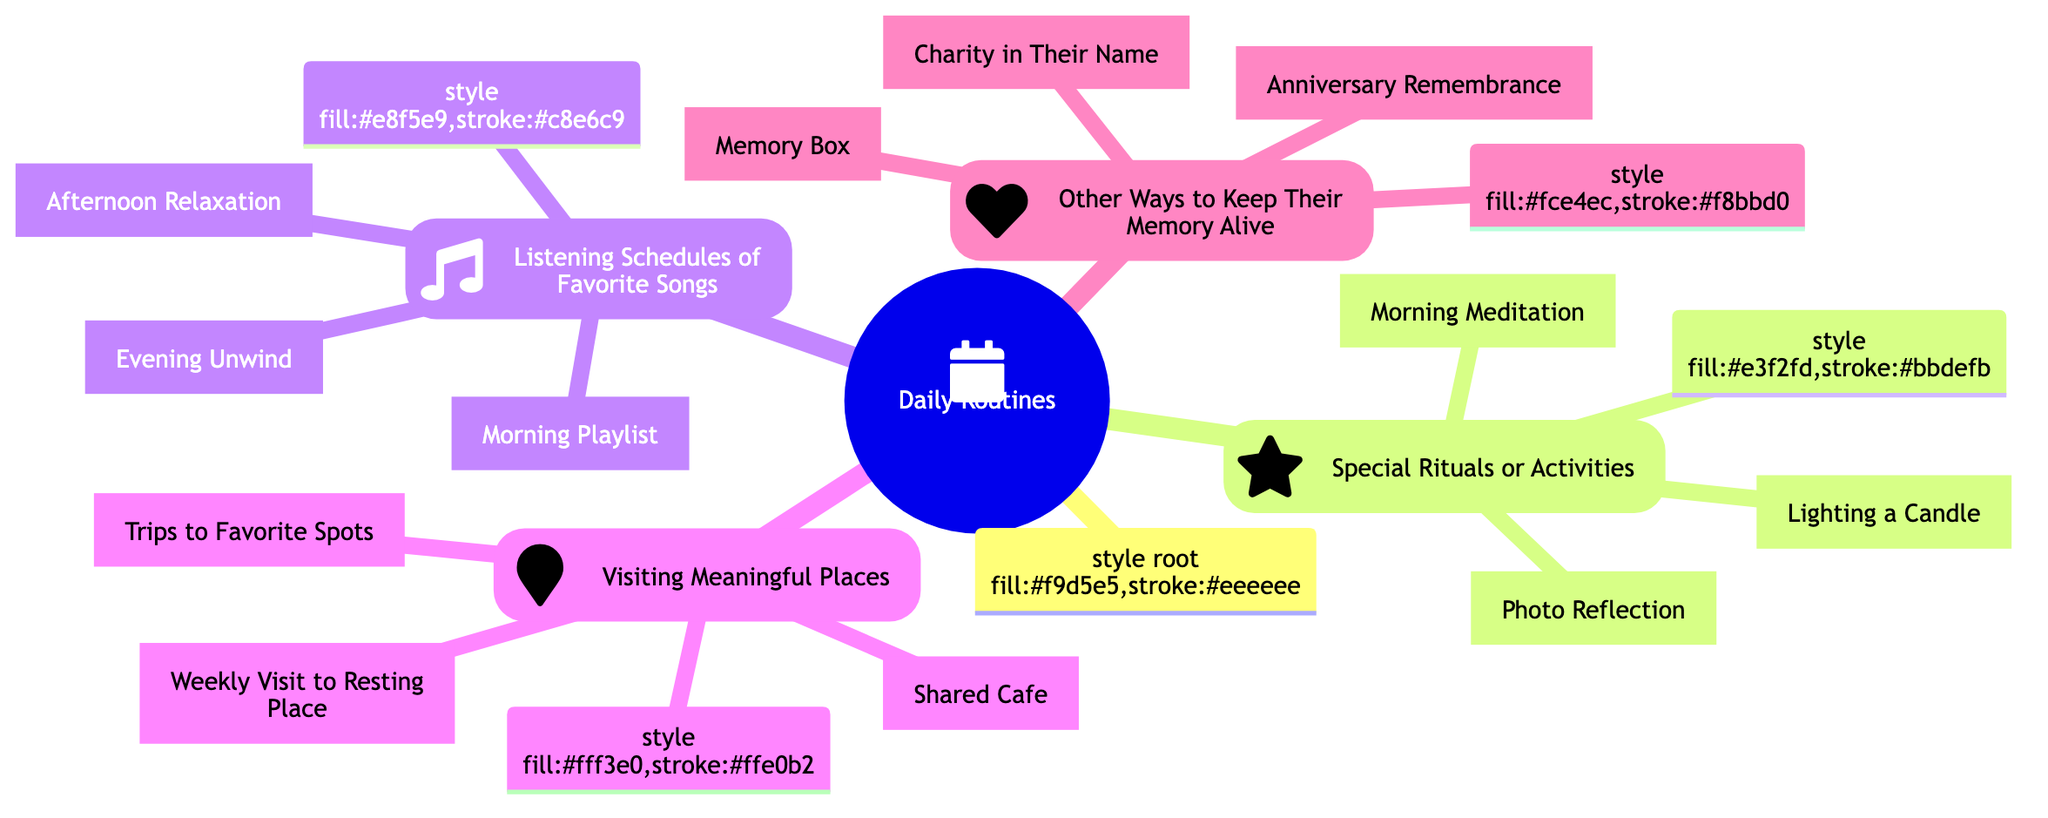What is the central node of the diagram? The diagram shows "Daily Routines" as the central node at the top of the structure, which is the main theme connecting all branches.
Answer: Daily Routines How many branches are there under "Daily Routines"? By examining the structure, there are four main branches stemming from "Daily Routines": Special Rituals or Activities, Listening Schedules of Favorite Songs, Visiting Meaningful Places, and Other Ways to Keep Their Memory Alive.
Answer: 4 Which branch includes "Morning Playlist"? "Morning Playlist" is located in the branch titled "Listening Schedules of Favorite Songs," indicating that it relates specifically to music and listening routines.
Answer: Listening Schedules of Favorite Songs What activity is listed under "Special Rituals or Activities"? The activities under this branch include Morning Meditation, Lighting a Candle, and Photo Reflection. For instance, "Lighting a Candle" is one of the specific activities designed to honor a loved one's memory.
Answer: Lighting a Candle Which way to keep their memory alive involves creating a physical box? The "Memory Box" is a specified practice listed under the "Other Ways to Keep Their Memory Alive" branch, emphasizing the creation of a tangible space for mementos and letters.
Answer: Memory Box If visiting the resting place is done weekly, what does that relate to? "Weekly Visit to Resting Place" falls under the branch titled "Visiting Meaningful Places," signifying that this activity is a significant ritual associated with honoring the memory of a loved one.
Answer: Visiting Meaningful Places Which branch addresses the concept of charity? The concept of charity is mentioned in the "Other Ways to Keep Their Memory Alive" branch, specifically referring to actions taken in a loved one’s name, like volunteering or donating.
Answer: Other Ways to Keep Their Memory Alive What is a common activity listed for the afternoon? In the "Listening Schedules of Favorite Songs" branch, the common activity for the afternoon is "Afternoon Relaxation," which includes playing favorite songs during lunchtime or breaks.
Answer: Afternoon Relaxation What type of activity is "Photo Reflection"? "Photo Reflection" is categorized under "Special Rituals or Activities," indicating it is a reflection or reminiscing activity designed to honor and remember a loved one through shared memories.
Answer: Special Rituals or Activities 